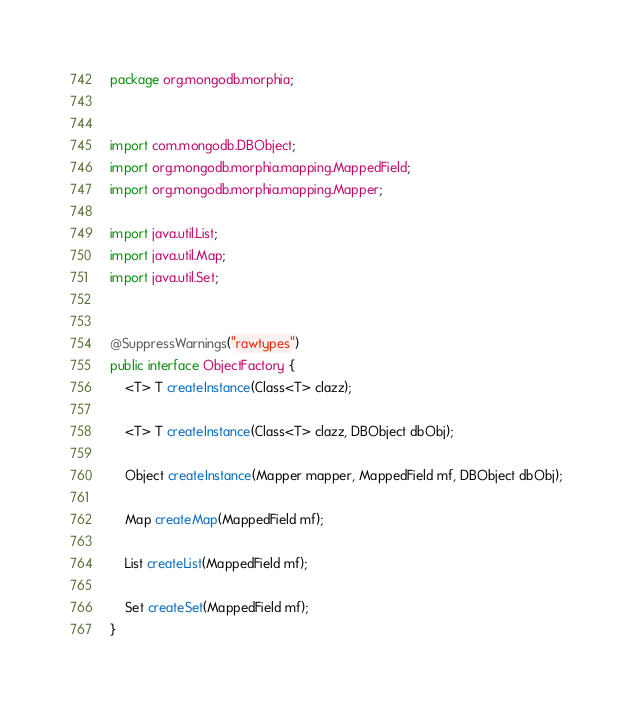Convert code to text. <code><loc_0><loc_0><loc_500><loc_500><_Java_>package org.mongodb.morphia;


import com.mongodb.DBObject;
import org.mongodb.morphia.mapping.MappedField;
import org.mongodb.morphia.mapping.Mapper;

import java.util.List;
import java.util.Map;
import java.util.Set;


@SuppressWarnings("rawtypes")
public interface ObjectFactory {
    <T> T createInstance(Class<T> clazz);

    <T> T createInstance(Class<T> clazz, DBObject dbObj);

    Object createInstance(Mapper mapper, MappedField mf, DBObject dbObj);

    Map createMap(MappedField mf);

    List createList(MappedField mf);

    Set createSet(MappedField mf);
}
</code> 